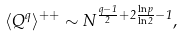<formula> <loc_0><loc_0><loc_500><loc_500>\langle Q ^ { q } \rangle ^ { + + } \sim N ^ { \frac { q - 1 } { 2 } + 2 \frac { \ln { p } } { \ln { 2 } } - 1 } ,</formula> 